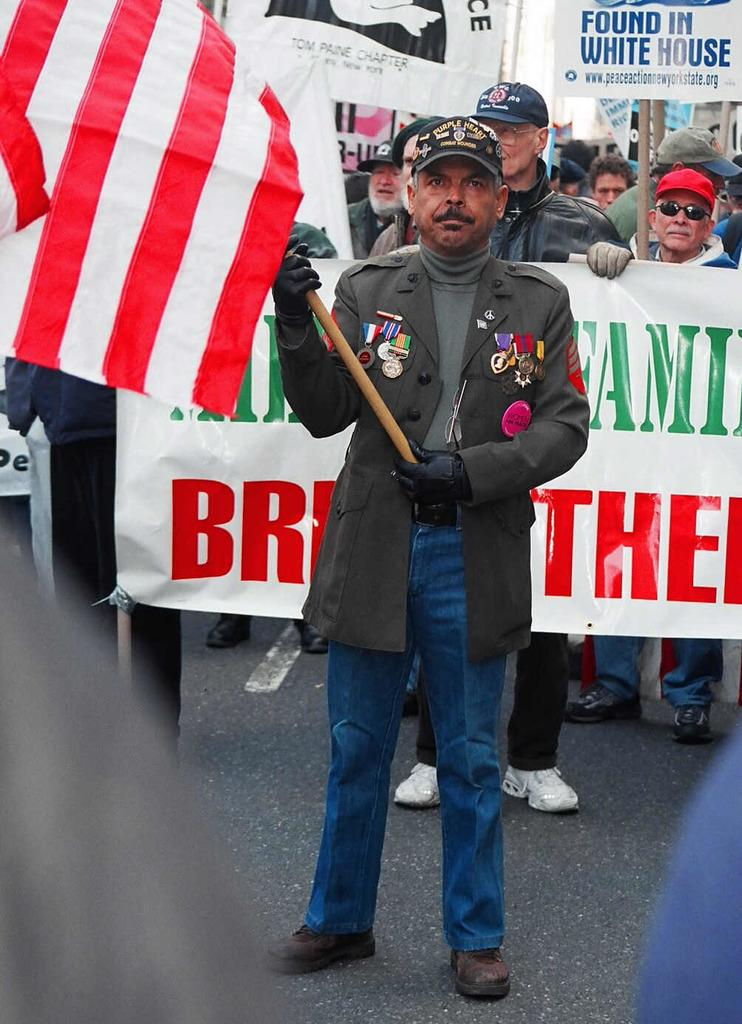What is the man in the image holding? The man is holding a flag. What are the other people in the image holding? The other people are holding placards. Is there anyone else holding something in the image? Yes, there is a person standing and holding a banner. What type of shock can be seen affecting the pest in the image? There is no pest present in the image, and therefore no shock can be observed. What type of agreement is being reached by the people in the image? The image does not provide enough information to determine if an agreement is being reached or what type of agreement it might be. 